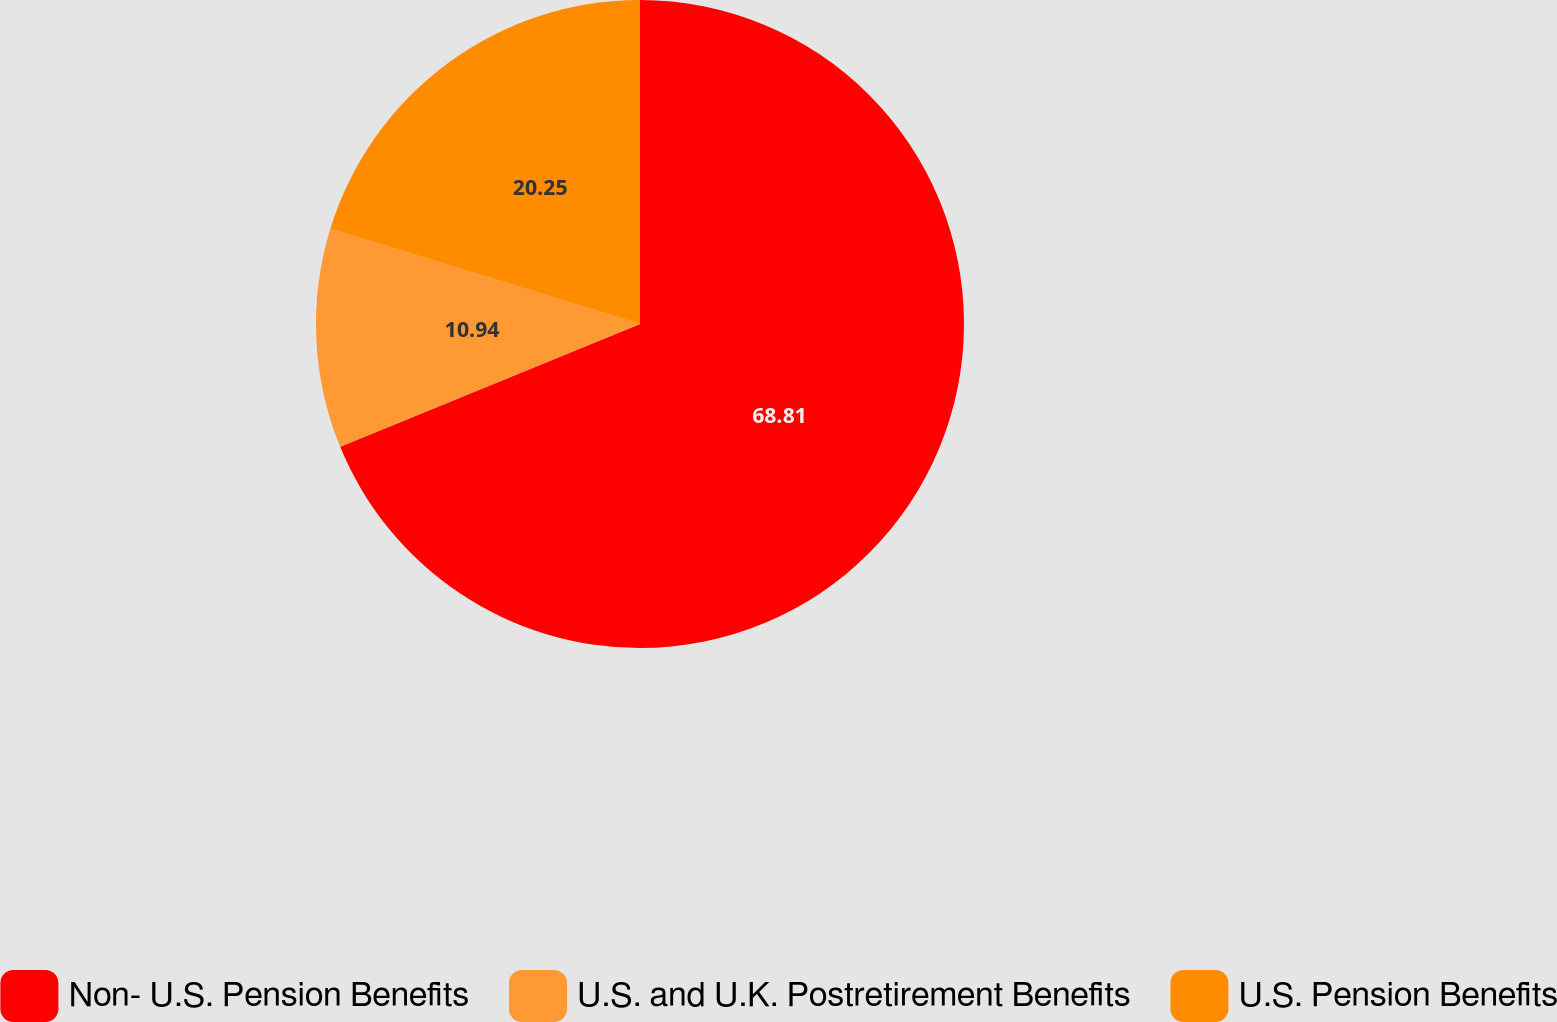Convert chart. <chart><loc_0><loc_0><loc_500><loc_500><pie_chart><fcel>Non- U.S. Pension Benefits<fcel>U.S. and U.K. Postretirement Benefits<fcel>U.S. Pension Benefits<nl><fcel>68.81%<fcel>10.94%<fcel>20.25%<nl></chart> 